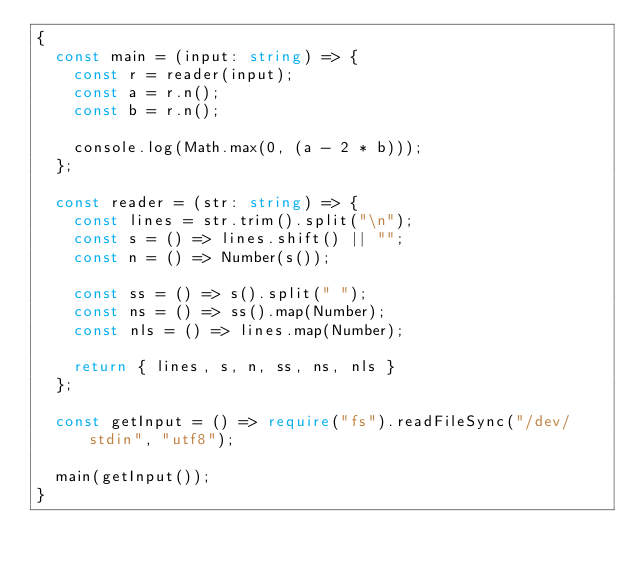<code> <loc_0><loc_0><loc_500><loc_500><_TypeScript_>{
  const main = (input: string) => {
    const r = reader(input);
    const a = r.n();
    const b = r.n();
    
    console.log(Math.max(0, (a - 2 * b)));
  };

  const reader = (str: string) => {
    const lines = str.trim().split("\n");
    const s = () => lines.shift() || "";
    const n = () => Number(s());

    const ss = () => s().split(" ");
    const ns = () => ss().map(Number);
    const nls = () => lines.map(Number);

    return { lines, s, n, ss, ns, nls }
  };

  const getInput = () => require("fs").readFileSync("/dev/stdin", "utf8");

  main(getInput());
}
</code> 